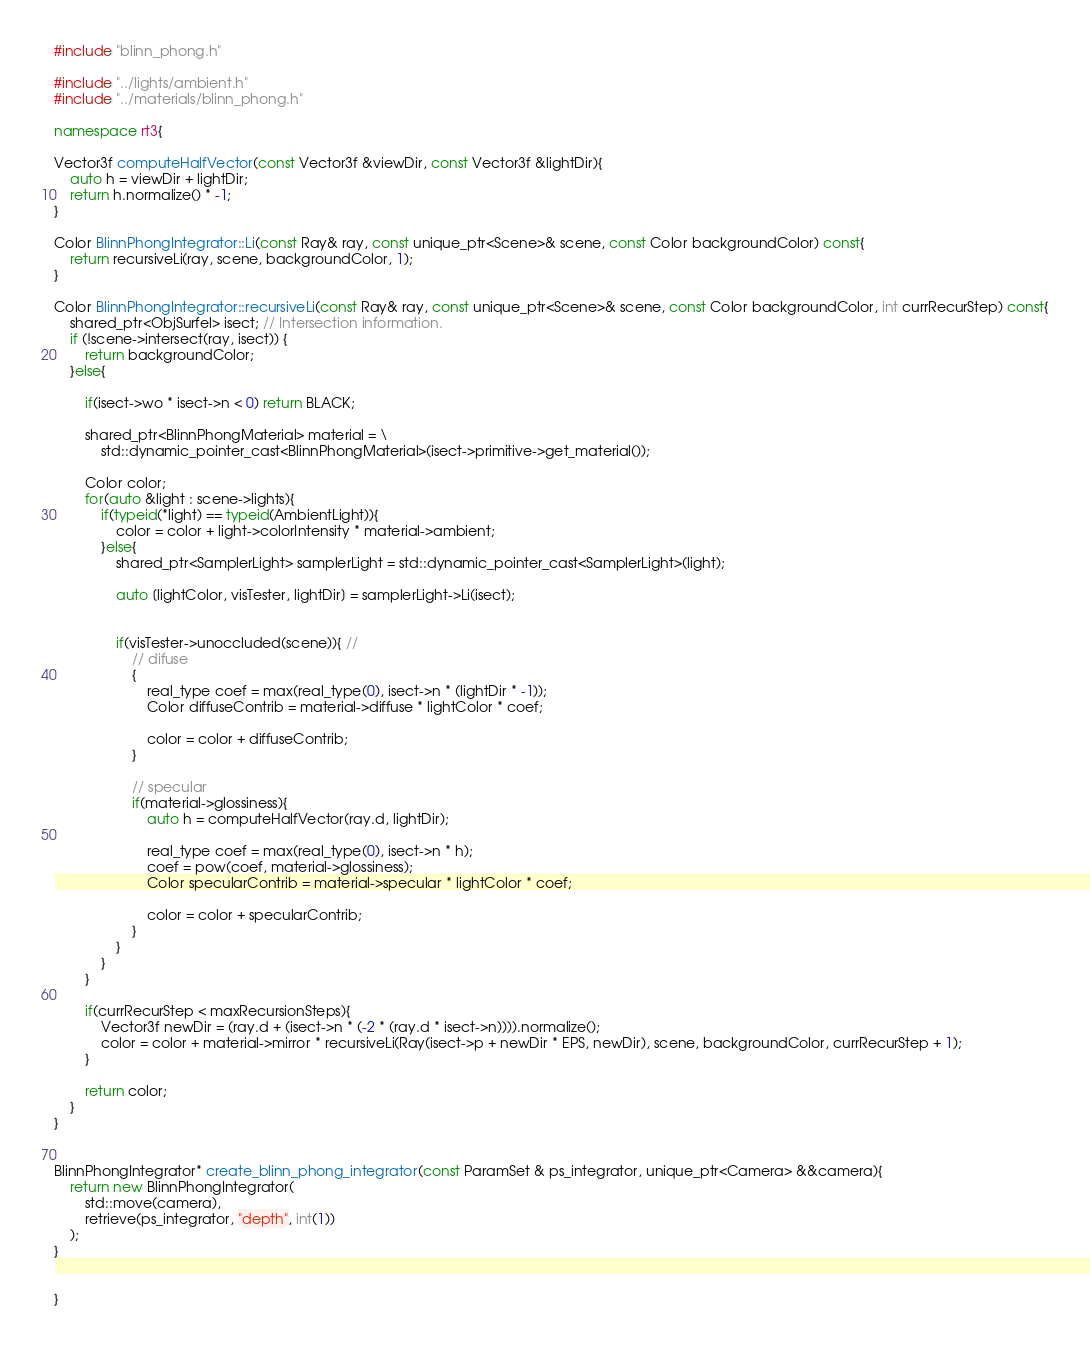Convert code to text. <code><loc_0><loc_0><loc_500><loc_500><_C++_>#include "blinn_phong.h"

#include "../lights/ambient.h"
#include "../materials/blinn_phong.h"

namespace rt3{

Vector3f computeHalfVector(const Vector3f &viewDir, const Vector3f &lightDir){
    auto h = viewDir + lightDir;
    return h.normalize() * -1;
}

Color BlinnPhongIntegrator::Li(const Ray& ray, const unique_ptr<Scene>& scene, const Color backgroundColor) const{
    return recursiveLi(ray, scene, backgroundColor, 1);
}

Color BlinnPhongIntegrator::recursiveLi(const Ray& ray, const unique_ptr<Scene>& scene, const Color backgroundColor, int currRecurStep) const{
    shared_ptr<ObjSurfel> isect; // Intersection information.  
    if (!scene->intersect(ray, isect)) {
        return backgroundColor;
    }else{

        if(isect->wo * isect->n < 0) return BLACK;

        shared_ptr<BlinnPhongMaterial> material = \
            std::dynamic_pointer_cast<BlinnPhongMaterial>(isect->primitive->get_material());

        Color color;
        for(auto &light : scene->lights){
            if(typeid(*light) == typeid(AmbientLight)){
                color = color + light->colorIntensity * material->ambient;
            }else{
                shared_ptr<SamplerLight> samplerLight = std::dynamic_pointer_cast<SamplerLight>(light);

                auto [lightColor, visTester, lightDir] = samplerLight->Li(isect);


                if(visTester->unoccluded(scene)){ // 
                    // difuse
                    {
                        real_type coef = max(real_type(0), isect->n * (lightDir * -1));
                        Color diffuseContrib = material->diffuse * lightColor * coef;
                        
                        color = color + diffuseContrib;
                    }
                    
                    // specular
                    if(material->glossiness){
                        auto h = computeHalfVector(ray.d, lightDir);

                        real_type coef = max(real_type(0), isect->n * h);
                        coef = pow(coef, material->glossiness);
                        Color specularContrib = material->specular * lightColor * coef;
                    
                        color = color + specularContrib;
                    }
                }
            }
        }

        if(currRecurStep < maxRecursionSteps){
            Vector3f newDir = (ray.d + (isect->n * (-2 * (ray.d * isect->n)))).normalize();
            color = color + material->mirror * recursiveLi(Ray(isect->p + newDir * EPS, newDir), scene, backgroundColor, currRecurStep + 1);
        }

        return color;
    }
}


BlinnPhongIntegrator* create_blinn_phong_integrator(const ParamSet & ps_integrator, unique_ptr<Camera> &&camera){
    return new BlinnPhongIntegrator(
        std::move(camera),
        retrieve(ps_integrator, "depth", int(1))
    );
}


}</code> 